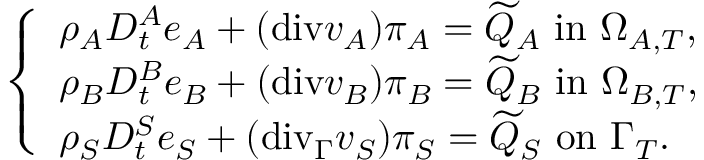Convert formula to latex. <formula><loc_0><loc_0><loc_500><loc_500>\left \{ \begin{array} { l l } { \rho _ { A } D _ { t } ^ { A } e _ { A } + ( { d i v } v _ { A } ) \pi _ { A } = \widetilde { Q } _ { A } i n \Omega _ { A , T } , } \\ { \rho _ { B } D _ { t } ^ { B } e _ { B } + ( { d i v } v _ { B } ) \pi _ { B } = \widetilde { Q } _ { B } i n \Omega _ { B , T } , } \\ { \rho _ { S } D _ { t } ^ { S } e _ { S } + ( { d i v } _ { \Gamma } v _ { S } ) \pi _ { S } = \widetilde { Q } _ { S } o n \Gamma _ { T } . } \end{array}</formula> 